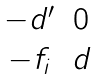Convert formula to latex. <formula><loc_0><loc_0><loc_500><loc_500>\begin{matrix} - d ^ { \prime } & 0 \\ - f _ { i } & d \end{matrix}</formula> 